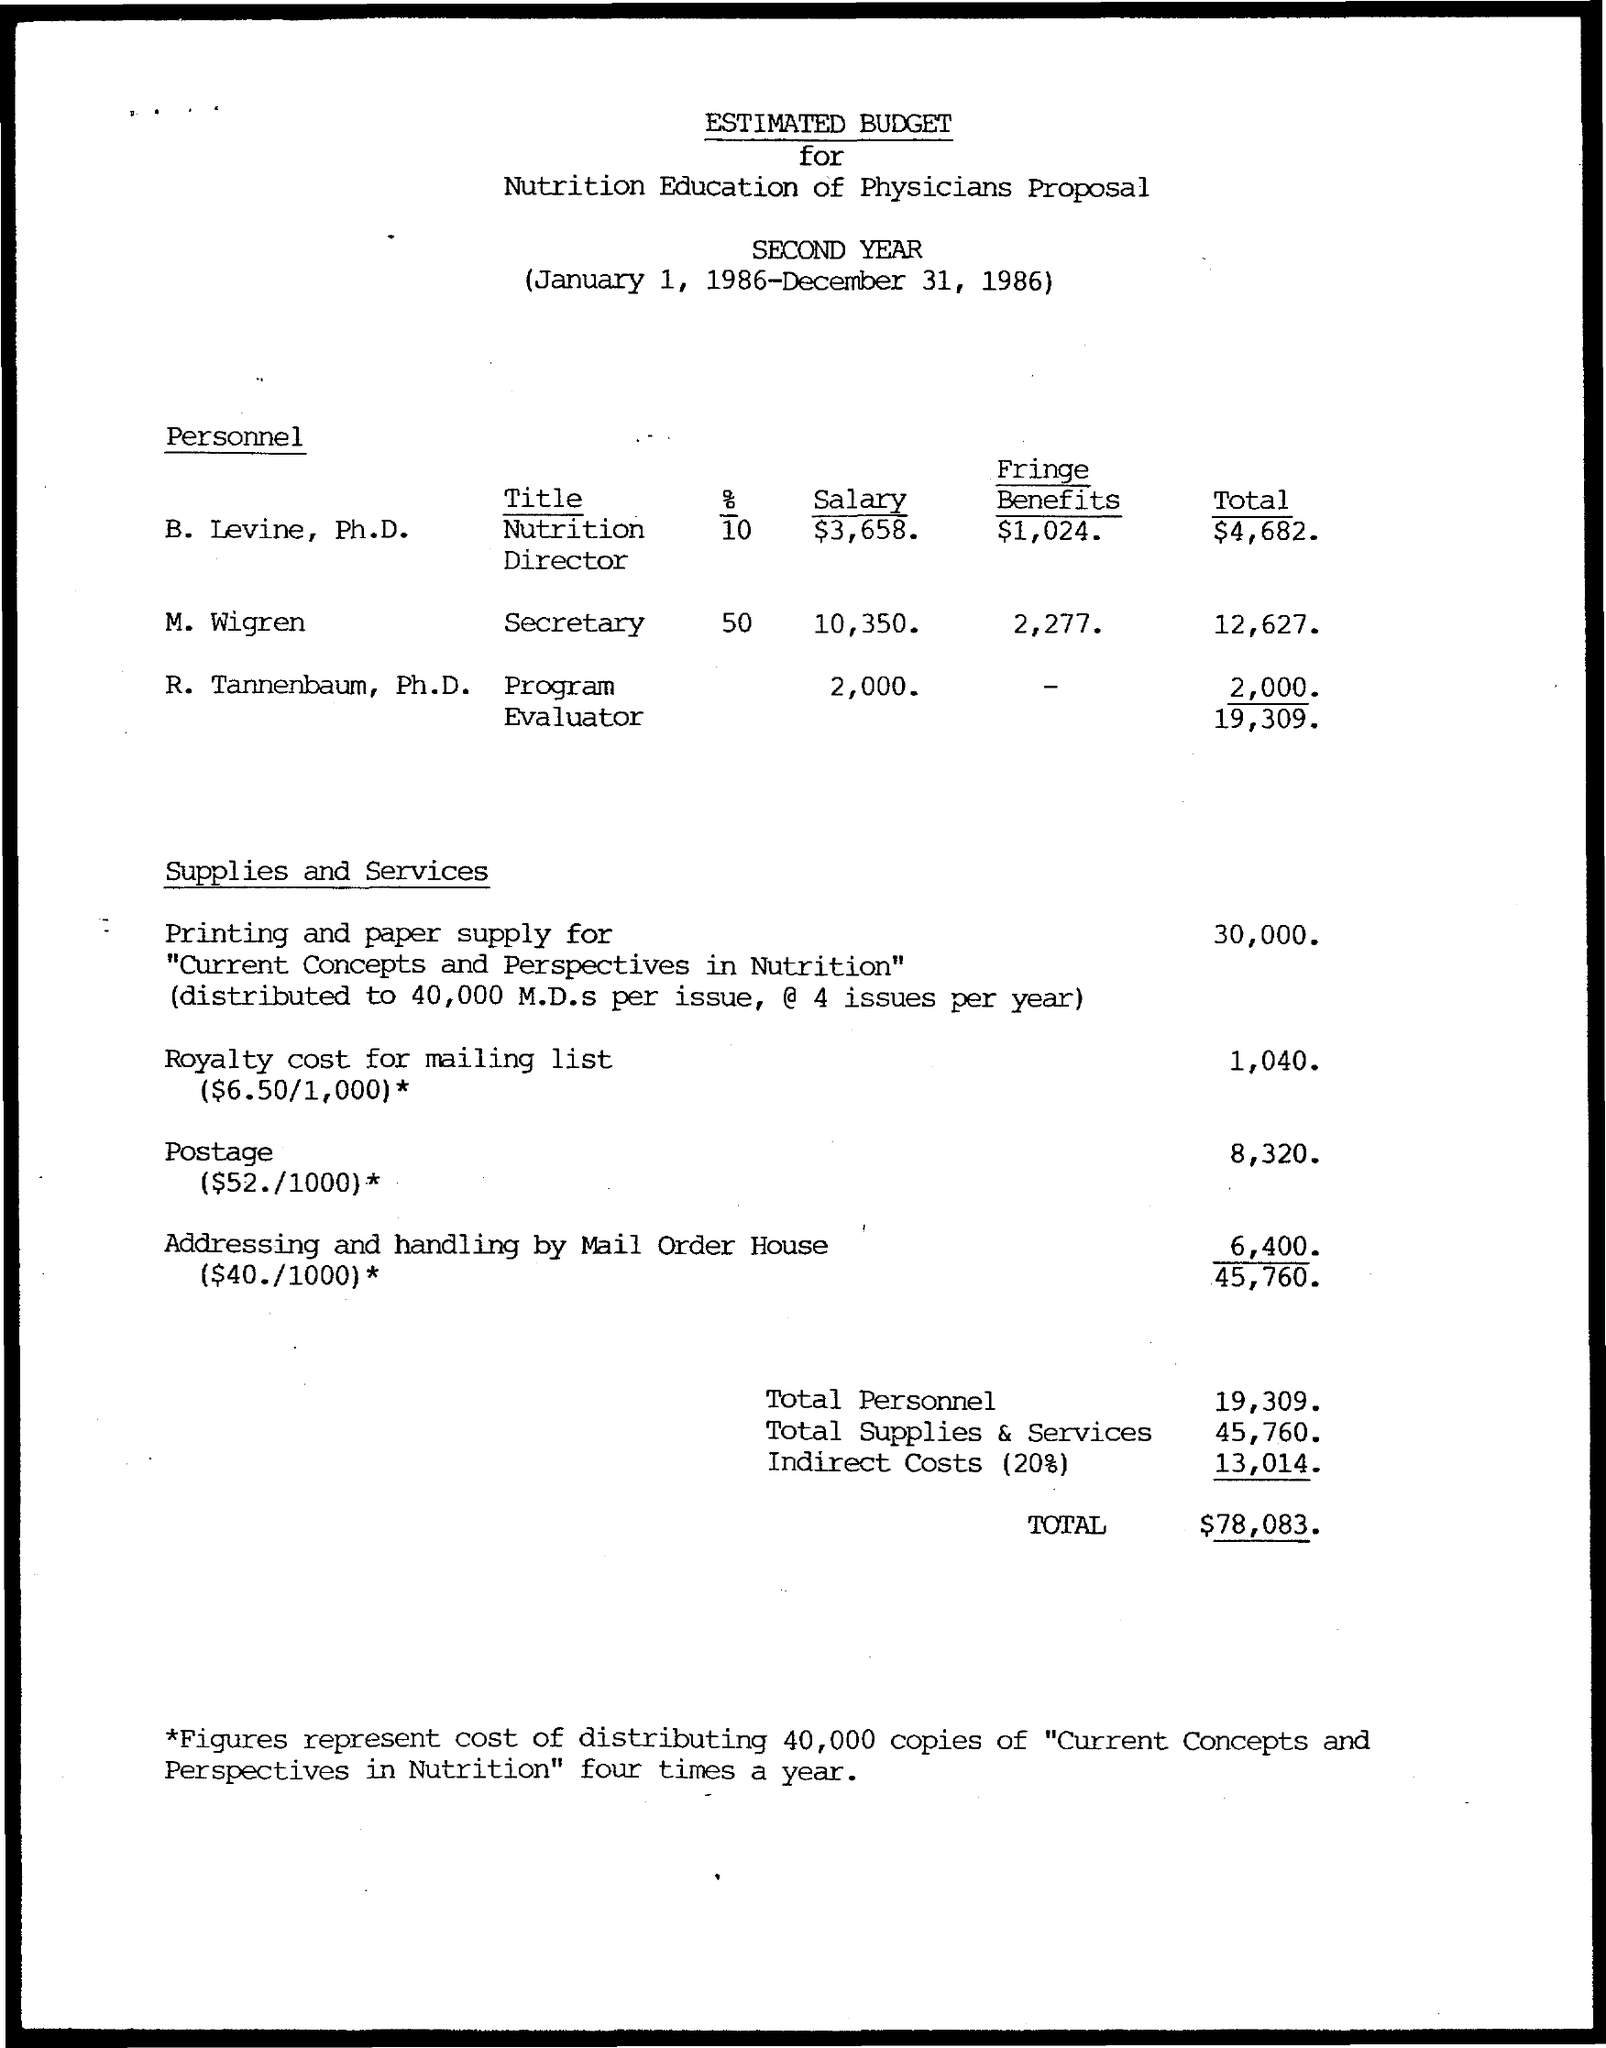What is the Title for Levine, Ph.D.?
Provide a short and direct response. Nutrition Director. What is the salary for Levine, Ph.D.?
Ensure brevity in your answer.  $3,658. What are the Fringe Benefits for Levine, Ph.D.?
Provide a short and direct response. $1,024. What is the Total for Levine, Ph.D.?
Make the answer very short. 4,682. What is the Title for Tannenbaum, Ph.D.?
Provide a succinct answer. Program Evaluator. What is the salary for Tannenbaum, Ph.D.?
Give a very brief answer. 2,000. What is the Total for Tannenbaum, Ph.D.?
Your answer should be very brief. 2,000. What is the Title for M. Wigren?
Your response must be concise. Secretary. What is the salary for M. Wigren?
Make the answer very short. 10,350. What is the Total for M. Wigren?
Ensure brevity in your answer.  12,627. 